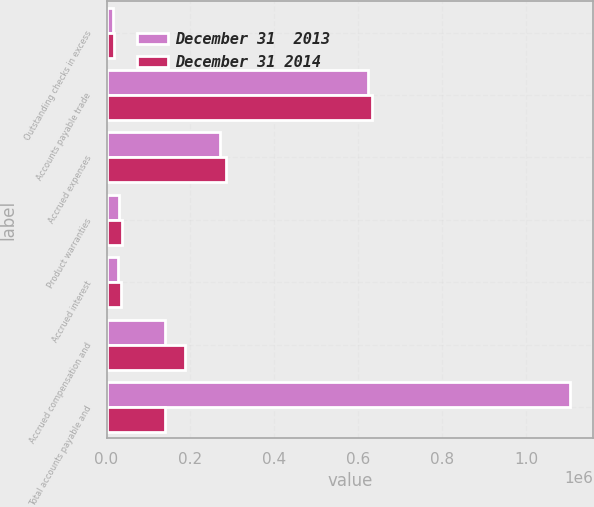<chart> <loc_0><loc_0><loc_500><loc_500><stacked_bar_chart><ecel><fcel>Outstanding checks in excess<fcel>Accounts payable trade<fcel>Accrued expenses<fcel>Product warranties<fcel>Accrued interest<fcel>Accrued compensation and<fcel>Total accounts payable and<nl><fcel>December 31  2013<fcel>16083<fcel>622360<fcel>269668<fcel>29350<fcel>28365<fcel>138683<fcel>1.10451e+06<nl><fcel>December 31 2014<fcel>18012<fcel>631732<fcel>285560<fcel>35818<fcel>35618<fcel>186853<fcel>138683<nl></chart> 